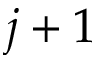Convert formula to latex. <formula><loc_0><loc_0><loc_500><loc_500>j + 1</formula> 